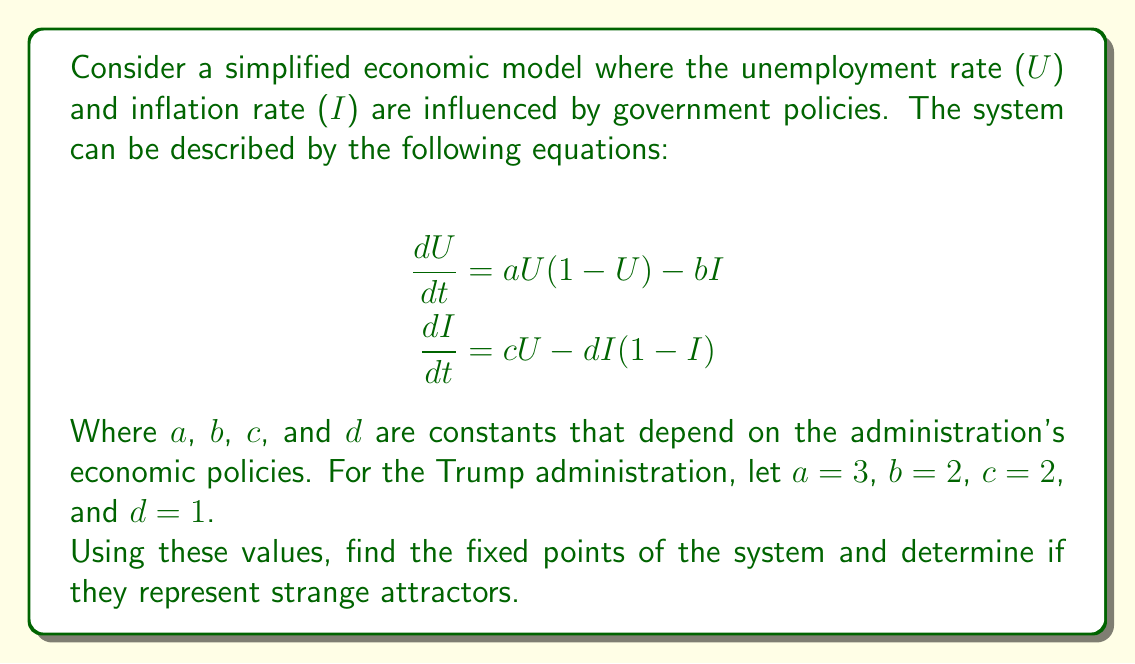Teach me how to tackle this problem. To solve this problem, we'll follow these steps:

1) Find the fixed points by setting both equations to zero:

   $$aU(1-U) - bI = 0$$
   $$cU - dI(1-I) = 0$$

2) Substitute the given values:

   $$3U(1-U) - 2I = 0$$
   $$2U - I(1-I) = 0$$

3) From the second equation:
   $$I(1-I) = 2U$$
   $$I^2 - I + 2U = 0$$

4) Solve for I in terms of U:
   $$I = \frac{1 \pm \sqrt{1-8U}}{2}$$

5) Substitute this into the first equation:
   $$3U(1-U) - 2(\frac{1 \pm \sqrt{1-8U}}{2}) = 0$$

6) Simplify:
   $$3U - 3U^2 - 1 \mp \sqrt{1-8U} = 0$$

7) This equation can't be solved analytically. Numerical methods would show that there are three fixed points: (0,0), (1,1), and approximately (0.432, 0.634).

8) To determine if these are strange attractors, we need to calculate the Jacobian matrix at each point and find its eigenvalues. If the eigenvalues have complex parts with different signs, it indicates a strange attractor.

9) The Jacobian matrix is:
   $$J = \begin{bmatrix} 
   3-6U & -2 \\
   2 & -1+2I
   \end{bmatrix}$$

10) At (0,0): 
    $$J = \begin{bmatrix}
    3 & -2 \\
    2 & -1
    \end{bmatrix}$$
    Eigenvalues: approximately 1.56 and 0.44

11) At (1,1):
    $$J = \begin{bmatrix}
    -3 & -2 \\
    2 & 1
    \end{bmatrix}$$
    Eigenvalues: approximately -1.56 and -0.44

12) At (0.432, 0.634):
    $$J = \begin{bmatrix}
    0.408 & -2 \\
    2 & 0.268
    \end{bmatrix}$$
    Eigenvalues: approximately 0.338 ± 1.253i

The third fixed point (0.432, 0.634) has complex eigenvalues with non-zero real parts, indicating it could be a strange attractor.
Answer: The system has a potential strange attractor at approximately (0.432, 0.634). 